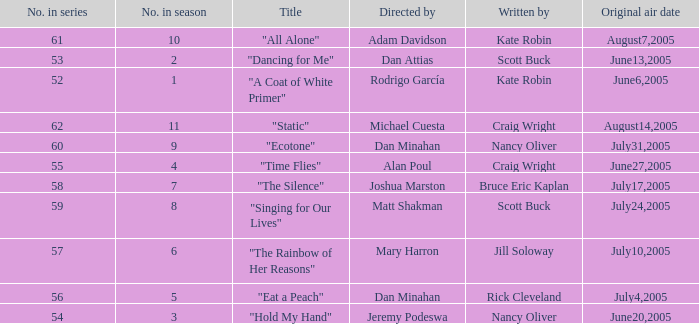What was the name of the episode that was directed by Mary Harron? "The Rainbow of Her Reasons". Would you mind parsing the complete table? {'header': ['No. in series', 'No. in season', 'Title', 'Directed by', 'Written by', 'Original air date'], 'rows': [['61', '10', '"All Alone"', 'Adam Davidson', 'Kate Robin', 'August7,2005'], ['53', '2', '"Dancing for Me"', 'Dan Attias', 'Scott Buck', 'June13,2005'], ['52', '1', '"A Coat of White Primer"', 'Rodrigo García', 'Kate Robin', 'June6,2005'], ['62', '11', '"Static"', 'Michael Cuesta', 'Craig Wright', 'August14,2005'], ['60', '9', '"Ecotone"', 'Dan Minahan', 'Nancy Oliver', 'July31,2005'], ['55', '4', '"Time Flies"', 'Alan Poul', 'Craig Wright', 'June27,2005'], ['58', '7', '"The Silence"', 'Joshua Marston', 'Bruce Eric Kaplan', 'July17,2005'], ['59', '8', '"Singing for Our Lives"', 'Matt Shakman', 'Scott Buck', 'July24,2005'], ['57', '6', '"The Rainbow of Her Reasons"', 'Mary Harron', 'Jill Soloway', 'July10,2005'], ['56', '5', '"Eat a Peach"', 'Dan Minahan', 'Rick Cleveland', 'July4,2005'], ['54', '3', '"Hold My Hand"', 'Jeremy Podeswa', 'Nancy Oliver', 'June20,2005']]} 